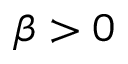<formula> <loc_0><loc_0><loc_500><loc_500>\beta > 0</formula> 